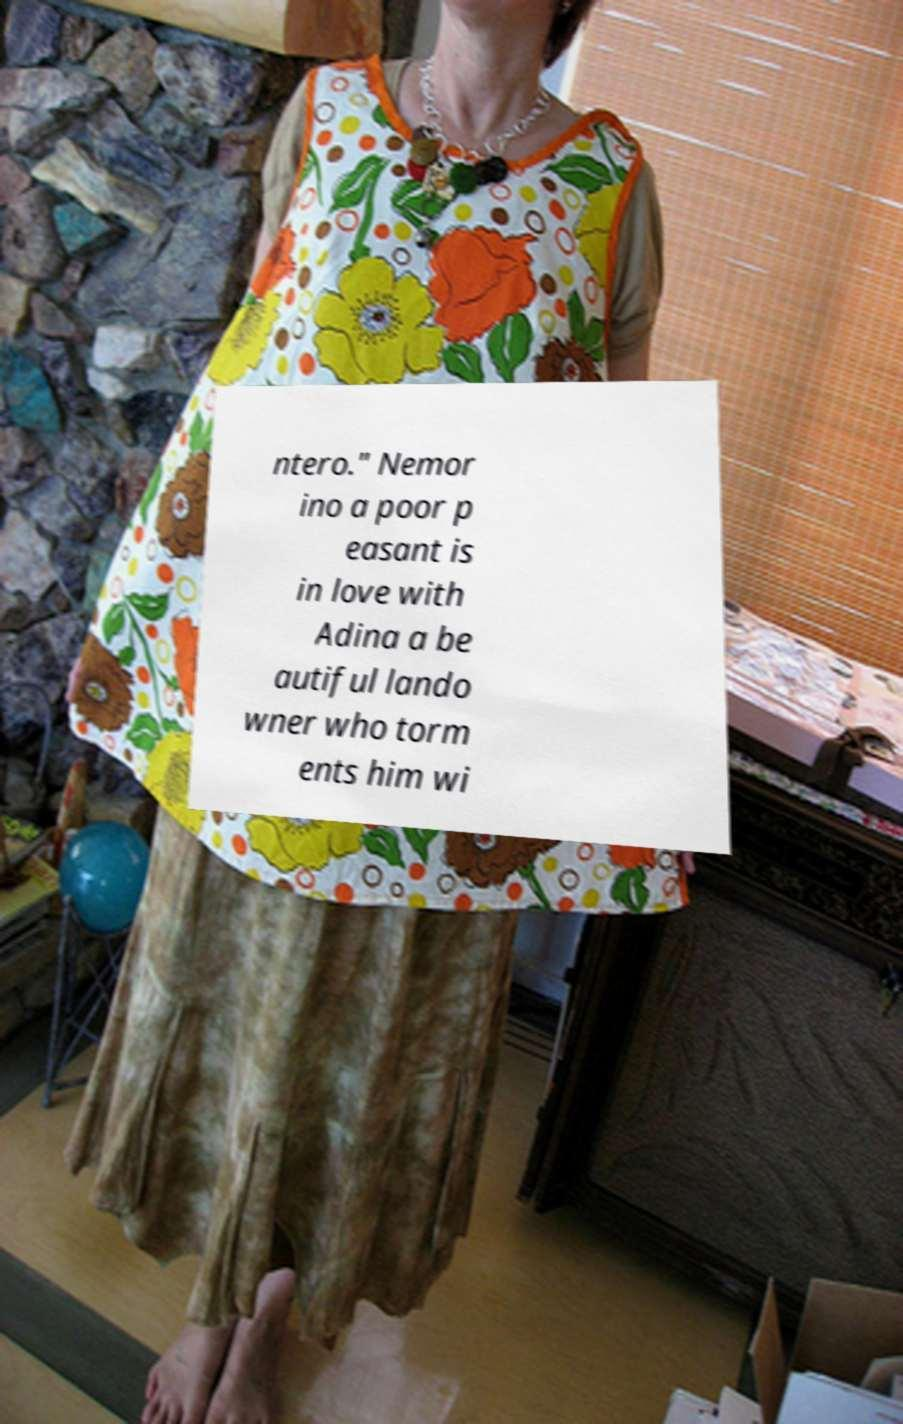There's text embedded in this image that I need extracted. Can you transcribe it verbatim? ntero." Nemor ino a poor p easant is in love with Adina a be autiful lando wner who torm ents him wi 